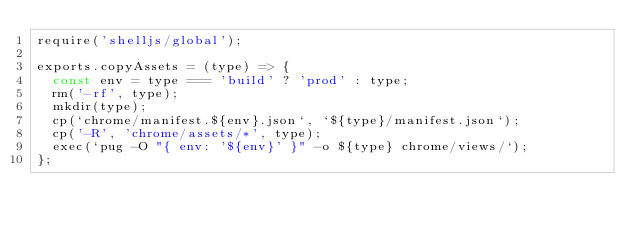Convert code to text. <code><loc_0><loc_0><loc_500><loc_500><_JavaScript_>require('shelljs/global');

exports.copyAssets = (type) => {
  const env = type === 'build' ? 'prod' : type;
  rm('-rf', type);
  mkdir(type);
  cp(`chrome/manifest.${env}.json`, `${type}/manifest.json`);
  cp('-R', 'chrome/assets/*', type);
  exec(`pug -O "{ env: '${env}' }" -o ${type} chrome/views/`);
};
</code> 